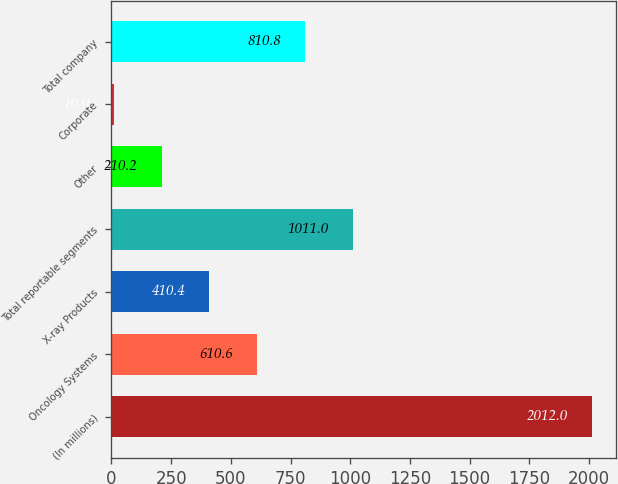Convert chart. <chart><loc_0><loc_0><loc_500><loc_500><bar_chart><fcel>(In millions)<fcel>Oncology Systems<fcel>X-ray Products<fcel>Total reportable segments<fcel>Other<fcel>Corporate<fcel>Total company<nl><fcel>2012<fcel>610.6<fcel>410.4<fcel>1011<fcel>210.2<fcel>10<fcel>810.8<nl></chart> 